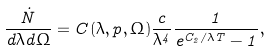Convert formula to latex. <formula><loc_0><loc_0><loc_500><loc_500>\frac { \dot { N } } { d \lambda d \Omega } = C ( \lambda , p , \Omega ) \frac { c } { \lambda ^ { 4 } } \frac { 1 } { e ^ { C _ { 2 } / \lambda T } - 1 } ,</formula> 